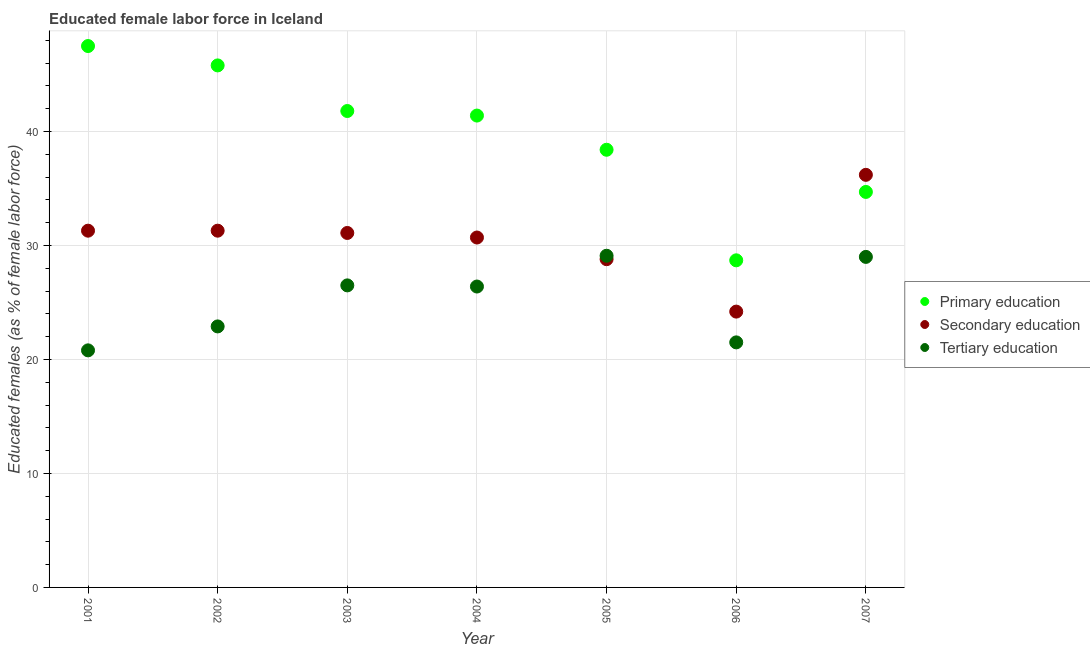Is the number of dotlines equal to the number of legend labels?
Make the answer very short. Yes. What is the percentage of female labor force who received tertiary education in 2007?
Keep it short and to the point. 29. Across all years, what is the maximum percentage of female labor force who received tertiary education?
Ensure brevity in your answer.  29.1. Across all years, what is the minimum percentage of female labor force who received secondary education?
Your answer should be compact. 24.2. In which year was the percentage of female labor force who received secondary education maximum?
Ensure brevity in your answer.  2007. In which year was the percentage of female labor force who received secondary education minimum?
Your answer should be compact. 2006. What is the total percentage of female labor force who received secondary education in the graph?
Your answer should be compact. 213.6. What is the difference between the percentage of female labor force who received primary education in 2004 and that in 2007?
Make the answer very short. 6.7. What is the difference between the percentage of female labor force who received primary education in 2002 and the percentage of female labor force who received tertiary education in 2005?
Your response must be concise. 16.7. What is the average percentage of female labor force who received primary education per year?
Make the answer very short. 39.76. In the year 2005, what is the difference between the percentage of female labor force who received primary education and percentage of female labor force who received secondary education?
Offer a very short reply. 9.6. In how many years, is the percentage of female labor force who received secondary education greater than 34 %?
Make the answer very short. 1. What is the ratio of the percentage of female labor force who received tertiary education in 2005 to that in 2007?
Your answer should be very brief. 1. Is the percentage of female labor force who received secondary education in 2004 less than that in 2005?
Give a very brief answer. No. Is the difference between the percentage of female labor force who received primary education in 2001 and 2006 greater than the difference between the percentage of female labor force who received tertiary education in 2001 and 2006?
Offer a terse response. Yes. What is the difference between the highest and the second highest percentage of female labor force who received primary education?
Make the answer very short. 1.7. What is the difference between the highest and the lowest percentage of female labor force who received primary education?
Your response must be concise. 18.8. Is it the case that in every year, the sum of the percentage of female labor force who received primary education and percentage of female labor force who received secondary education is greater than the percentage of female labor force who received tertiary education?
Ensure brevity in your answer.  Yes. Is the percentage of female labor force who received tertiary education strictly less than the percentage of female labor force who received secondary education over the years?
Your answer should be very brief. No. How many dotlines are there?
Your response must be concise. 3. What is the difference between two consecutive major ticks on the Y-axis?
Your answer should be very brief. 10. Are the values on the major ticks of Y-axis written in scientific E-notation?
Make the answer very short. No. Does the graph contain any zero values?
Provide a succinct answer. No. Does the graph contain grids?
Ensure brevity in your answer.  Yes. Where does the legend appear in the graph?
Provide a short and direct response. Center right. What is the title of the graph?
Your answer should be very brief. Educated female labor force in Iceland. What is the label or title of the X-axis?
Provide a short and direct response. Year. What is the label or title of the Y-axis?
Offer a terse response. Educated females (as % of female labor force). What is the Educated females (as % of female labor force) in Primary education in 2001?
Your answer should be compact. 47.5. What is the Educated females (as % of female labor force) in Secondary education in 2001?
Keep it short and to the point. 31.3. What is the Educated females (as % of female labor force) of Tertiary education in 2001?
Your answer should be very brief. 20.8. What is the Educated females (as % of female labor force) of Primary education in 2002?
Offer a terse response. 45.8. What is the Educated females (as % of female labor force) of Secondary education in 2002?
Provide a succinct answer. 31.3. What is the Educated females (as % of female labor force) in Tertiary education in 2002?
Offer a very short reply. 22.9. What is the Educated females (as % of female labor force) in Primary education in 2003?
Your answer should be compact. 41.8. What is the Educated females (as % of female labor force) of Secondary education in 2003?
Make the answer very short. 31.1. What is the Educated females (as % of female labor force) of Tertiary education in 2003?
Keep it short and to the point. 26.5. What is the Educated females (as % of female labor force) of Primary education in 2004?
Ensure brevity in your answer.  41.4. What is the Educated females (as % of female labor force) in Secondary education in 2004?
Offer a very short reply. 30.7. What is the Educated females (as % of female labor force) of Tertiary education in 2004?
Offer a very short reply. 26.4. What is the Educated females (as % of female labor force) in Primary education in 2005?
Make the answer very short. 38.4. What is the Educated females (as % of female labor force) in Secondary education in 2005?
Keep it short and to the point. 28.8. What is the Educated females (as % of female labor force) of Tertiary education in 2005?
Provide a short and direct response. 29.1. What is the Educated females (as % of female labor force) of Primary education in 2006?
Provide a short and direct response. 28.7. What is the Educated females (as % of female labor force) in Secondary education in 2006?
Keep it short and to the point. 24.2. What is the Educated females (as % of female labor force) of Tertiary education in 2006?
Your answer should be very brief. 21.5. What is the Educated females (as % of female labor force) in Primary education in 2007?
Make the answer very short. 34.7. What is the Educated females (as % of female labor force) in Secondary education in 2007?
Your response must be concise. 36.2. What is the Educated females (as % of female labor force) in Tertiary education in 2007?
Your answer should be compact. 29. Across all years, what is the maximum Educated females (as % of female labor force) of Primary education?
Ensure brevity in your answer.  47.5. Across all years, what is the maximum Educated females (as % of female labor force) in Secondary education?
Your response must be concise. 36.2. Across all years, what is the maximum Educated females (as % of female labor force) in Tertiary education?
Your answer should be very brief. 29.1. Across all years, what is the minimum Educated females (as % of female labor force) of Primary education?
Provide a short and direct response. 28.7. Across all years, what is the minimum Educated females (as % of female labor force) of Secondary education?
Your answer should be compact. 24.2. Across all years, what is the minimum Educated females (as % of female labor force) in Tertiary education?
Provide a short and direct response. 20.8. What is the total Educated females (as % of female labor force) in Primary education in the graph?
Provide a short and direct response. 278.3. What is the total Educated females (as % of female labor force) of Secondary education in the graph?
Keep it short and to the point. 213.6. What is the total Educated females (as % of female labor force) in Tertiary education in the graph?
Your answer should be compact. 176.2. What is the difference between the Educated females (as % of female labor force) of Primary education in 2001 and that in 2002?
Ensure brevity in your answer.  1.7. What is the difference between the Educated females (as % of female labor force) of Tertiary education in 2001 and that in 2002?
Make the answer very short. -2.1. What is the difference between the Educated females (as % of female labor force) of Tertiary education in 2001 and that in 2003?
Make the answer very short. -5.7. What is the difference between the Educated females (as % of female labor force) in Secondary education in 2001 and that in 2004?
Make the answer very short. 0.6. What is the difference between the Educated females (as % of female labor force) of Tertiary education in 2001 and that in 2004?
Provide a short and direct response. -5.6. What is the difference between the Educated females (as % of female labor force) in Primary education in 2001 and that in 2005?
Keep it short and to the point. 9.1. What is the difference between the Educated females (as % of female labor force) in Tertiary education in 2001 and that in 2005?
Offer a very short reply. -8.3. What is the difference between the Educated females (as % of female labor force) of Tertiary education in 2001 and that in 2006?
Your answer should be compact. -0.7. What is the difference between the Educated females (as % of female labor force) in Primary education in 2001 and that in 2007?
Your answer should be compact. 12.8. What is the difference between the Educated females (as % of female labor force) of Secondary education in 2001 and that in 2007?
Offer a very short reply. -4.9. What is the difference between the Educated females (as % of female labor force) of Tertiary education in 2001 and that in 2007?
Your response must be concise. -8.2. What is the difference between the Educated females (as % of female labor force) of Primary education in 2002 and that in 2003?
Provide a succinct answer. 4. What is the difference between the Educated females (as % of female labor force) of Tertiary education in 2002 and that in 2003?
Make the answer very short. -3.6. What is the difference between the Educated females (as % of female labor force) of Primary education in 2002 and that in 2004?
Make the answer very short. 4.4. What is the difference between the Educated females (as % of female labor force) of Tertiary education in 2002 and that in 2004?
Offer a terse response. -3.5. What is the difference between the Educated females (as % of female labor force) of Primary education in 2002 and that in 2005?
Offer a terse response. 7.4. What is the difference between the Educated females (as % of female labor force) in Tertiary education in 2002 and that in 2005?
Provide a succinct answer. -6.2. What is the difference between the Educated females (as % of female labor force) in Primary education in 2002 and that in 2006?
Make the answer very short. 17.1. What is the difference between the Educated females (as % of female labor force) of Secondary education in 2002 and that in 2006?
Your response must be concise. 7.1. What is the difference between the Educated females (as % of female labor force) in Tertiary education in 2002 and that in 2006?
Offer a terse response. 1.4. What is the difference between the Educated females (as % of female labor force) of Secondary education in 2002 and that in 2007?
Your answer should be very brief. -4.9. What is the difference between the Educated females (as % of female labor force) in Tertiary education in 2002 and that in 2007?
Offer a very short reply. -6.1. What is the difference between the Educated females (as % of female labor force) of Primary education in 2003 and that in 2004?
Offer a very short reply. 0.4. What is the difference between the Educated females (as % of female labor force) in Tertiary education in 2003 and that in 2004?
Provide a short and direct response. 0.1. What is the difference between the Educated females (as % of female labor force) of Secondary education in 2003 and that in 2005?
Offer a very short reply. 2.3. What is the difference between the Educated females (as % of female labor force) of Tertiary education in 2003 and that in 2006?
Your answer should be very brief. 5. What is the difference between the Educated females (as % of female labor force) in Primary education in 2003 and that in 2007?
Your answer should be very brief. 7.1. What is the difference between the Educated females (as % of female labor force) of Tertiary education in 2003 and that in 2007?
Make the answer very short. -2.5. What is the difference between the Educated females (as % of female labor force) in Primary education in 2004 and that in 2005?
Give a very brief answer. 3. What is the difference between the Educated females (as % of female labor force) in Secondary education in 2004 and that in 2005?
Your response must be concise. 1.9. What is the difference between the Educated females (as % of female labor force) of Tertiary education in 2004 and that in 2005?
Provide a short and direct response. -2.7. What is the difference between the Educated females (as % of female labor force) of Primary education in 2004 and that in 2006?
Provide a succinct answer. 12.7. What is the difference between the Educated females (as % of female labor force) in Primary education in 2004 and that in 2007?
Keep it short and to the point. 6.7. What is the difference between the Educated females (as % of female labor force) of Primary education in 2005 and that in 2006?
Offer a very short reply. 9.7. What is the difference between the Educated females (as % of female labor force) of Secondary education in 2005 and that in 2006?
Keep it short and to the point. 4.6. What is the difference between the Educated females (as % of female labor force) in Tertiary education in 2005 and that in 2006?
Offer a terse response. 7.6. What is the difference between the Educated females (as % of female labor force) in Primary education in 2006 and that in 2007?
Make the answer very short. -6. What is the difference between the Educated females (as % of female labor force) in Secondary education in 2006 and that in 2007?
Offer a terse response. -12. What is the difference between the Educated females (as % of female labor force) of Primary education in 2001 and the Educated females (as % of female labor force) of Secondary education in 2002?
Offer a very short reply. 16.2. What is the difference between the Educated females (as % of female labor force) of Primary education in 2001 and the Educated females (as % of female labor force) of Tertiary education in 2002?
Provide a short and direct response. 24.6. What is the difference between the Educated females (as % of female labor force) of Secondary education in 2001 and the Educated females (as % of female labor force) of Tertiary education in 2002?
Ensure brevity in your answer.  8.4. What is the difference between the Educated females (as % of female labor force) of Primary education in 2001 and the Educated females (as % of female labor force) of Secondary education in 2003?
Provide a short and direct response. 16.4. What is the difference between the Educated females (as % of female labor force) of Primary education in 2001 and the Educated females (as % of female labor force) of Secondary education in 2004?
Offer a very short reply. 16.8. What is the difference between the Educated females (as % of female labor force) of Primary education in 2001 and the Educated females (as % of female labor force) of Tertiary education in 2004?
Provide a short and direct response. 21.1. What is the difference between the Educated females (as % of female labor force) in Primary education in 2001 and the Educated females (as % of female labor force) in Secondary education in 2005?
Provide a short and direct response. 18.7. What is the difference between the Educated females (as % of female labor force) of Secondary education in 2001 and the Educated females (as % of female labor force) of Tertiary education in 2005?
Provide a short and direct response. 2.2. What is the difference between the Educated females (as % of female labor force) in Primary education in 2001 and the Educated females (as % of female labor force) in Secondary education in 2006?
Provide a succinct answer. 23.3. What is the difference between the Educated females (as % of female labor force) of Primary education in 2001 and the Educated females (as % of female labor force) of Tertiary education in 2007?
Your answer should be very brief. 18.5. What is the difference between the Educated females (as % of female labor force) in Primary education in 2002 and the Educated females (as % of female labor force) in Tertiary education in 2003?
Your answer should be compact. 19.3. What is the difference between the Educated females (as % of female labor force) in Primary education in 2002 and the Educated females (as % of female labor force) in Secondary education in 2004?
Your answer should be very brief. 15.1. What is the difference between the Educated females (as % of female labor force) in Primary education in 2002 and the Educated females (as % of female labor force) in Secondary education in 2005?
Offer a terse response. 17. What is the difference between the Educated females (as % of female labor force) in Primary education in 2002 and the Educated females (as % of female labor force) in Tertiary education in 2005?
Ensure brevity in your answer.  16.7. What is the difference between the Educated females (as % of female labor force) of Primary education in 2002 and the Educated females (as % of female labor force) of Secondary education in 2006?
Make the answer very short. 21.6. What is the difference between the Educated females (as % of female labor force) in Primary education in 2002 and the Educated females (as % of female labor force) in Tertiary education in 2006?
Keep it short and to the point. 24.3. What is the difference between the Educated females (as % of female labor force) in Secondary education in 2002 and the Educated females (as % of female labor force) in Tertiary education in 2006?
Provide a short and direct response. 9.8. What is the difference between the Educated females (as % of female labor force) in Primary education in 2002 and the Educated females (as % of female labor force) in Secondary education in 2007?
Make the answer very short. 9.6. What is the difference between the Educated females (as % of female labor force) of Primary education in 2003 and the Educated females (as % of female labor force) of Tertiary education in 2004?
Provide a short and direct response. 15.4. What is the difference between the Educated females (as % of female labor force) of Secondary education in 2003 and the Educated females (as % of female labor force) of Tertiary education in 2004?
Give a very brief answer. 4.7. What is the difference between the Educated females (as % of female labor force) in Primary education in 2003 and the Educated females (as % of female labor force) in Tertiary education in 2006?
Provide a succinct answer. 20.3. What is the difference between the Educated females (as % of female labor force) of Secondary education in 2003 and the Educated females (as % of female labor force) of Tertiary education in 2006?
Make the answer very short. 9.6. What is the difference between the Educated females (as % of female labor force) in Primary education in 2003 and the Educated females (as % of female labor force) in Secondary education in 2007?
Provide a short and direct response. 5.6. What is the difference between the Educated females (as % of female labor force) of Primary education in 2004 and the Educated females (as % of female labor force) of Tertiary education in 2005?
Your answer should be compact. 12.3. What is the difference between the Educated females (as % of female labor force) in Primary education in 2004 and the Educated females (as % of female labor force) in Secondary education in 2006?
Provide a succinct answer. 17.2. What is the difference between the Educated females (as % of female labor force) in Primary education in 2004 and the Educated females (as % of female labor force) in Tertiary education in 2006?
Offer a very short reply. 19.9. What is the difference between the Educated females (as % of female labor force) in Secondary education in 2004 and the Educated females (as % of female labor force) in Tertiary education in 2006?
Give a very brief answer. 9.2. What is the difference between the Educated females (as % of female labor force) of Secondary education in 2004 and the Educated females (as % of female labor force) of Tertiary education in 2007?
Provide a short and direct response. 1.7. What is the difference between the Educated females (as % of female labor force) in Primary education in 2005 and the Educated females (as % of female labor force) in Tertiary education in 2006?
Keep it short and to the point. 16.9. What is the difference between the Educated females (as % of female labor force) in Primary education in 2006 and the Educated females (as % of female labor force) in Secondary education in 2007?
Make the answer very short. -7.5. What is the difference between the Educated females (as % of female labor force) in Secondary education in 2006 and the Educated females (as % of female labor force) in Tertiary education in 2007?
Provide a short and direct response. -4.8. What is the average Educated females (as % of female labor force) of Primary education per year?
Offer a terse response. 39.76. What is the average Educated females (as % of female labor force) in Secondary education per year?
Your answer should be compact. 30.51. What is the average Educated females (as % of female labor force) in Tertiary education per year?
Provide a short and direct response. 25.17. In the year 2001, what is the difference between the Educated females (as % of female labor force) in Primary education and Educated females (as % of female labor force) in Secondary education?
Make the answer very short. 16.2. In the year 2001, what is the difference between the Educated females (as % of female labor force) in Primary education and Educated females (as % of female labor force) in Tertiary education?
Keep it short and to the point. 26.7. In the year 2002, what is the difference between the Educated females (as % of female labor force) of Primary education and Educated females (as % of female labor force) of Secondary education?
Your answer should be very brief. 14.5. In the year 2002, what is the difference between the Educated females (as % of female labor force) of Primary education and Educated females (as % of female labor force) of Tertiary education?
Provide a short and direct response. 22.9. In the year 2003, what is the difference between the Educated females (as % of female labor force) in Primary education and Educated females (as % of female labor force) in Tertiary education?
Your answer should be very brief. 15.3. In the year 2003, what is the difference between the Educated females (as % of female labor force) of Secondary education and Educated females (as % of female labor force) of Tertiary education?
Offer a very short reply. 4.6. In the year 2004, what is the difference between the Educated females (as % of female labor force) in Primary education and Educated females (as % of female labor force) in Secondary education?
Your answer should be compact. 10.7. In the year 2004, what is the difference between the Educated females (as % of female labor force) of Secondary education and Educated females (as % of female labor force) of Tertiary education?
Offer a terse response. 4.3. In the year 2005, what is the difference between the Educated females (as % of female labor force) of Primary education and Educated females (as % of female labor force) of Tertiary education?
Ensure brevity in your answer.  9.3. In the year 2005, what is the difference between the Educated females (as % of female labor force) of Secondary education and Educated females (as % of female labor force) of Tertiary education?
Offer a very short reply. -0.3. In the year 2006, what is the difference between the Educated females (as % of female labor force) in Primary education and Educated females (as % of female labor force) in Secondary education?
Give a very brief answer. 4.5. In the year 2006, what is the difference between the Educated females (as % of female labor force) of Secondary education and Educated females (as % of female labor force) of Tertiary education?
Your answer should be compact. 2.7. In the year 2007, what is the difference between the Educated females (as % of female labor force) of Primary education and Educated females (as % of female labor force) of Secondary education?
Give a very brief answer. -1.5. In the year 2007, what is the difference between the Educated females (as % of female labor force) in Secondary education and Educated females (as % of female labor force) in Tertiary education?
Provide a succinct answer. 7.2. What is the ratio of the Educated females (as % of female labor force) of Primary education in 2001 to that in 2002?
Keep it short and to the point. 1.04. What is the ratio of the Educated females (as % of female labor force) of Tertiary education in 2001 to that in 2002?
Your response must be concise. 0.91. What is the ratio of the Educated females (as % of female labor force) of Primary education in 2001 to that in 2003?
Your answer should be compact. 1.14. What is the ratio of the Educated females (as % of female labor force) of Secondary education in 2001 to that in 2003?
Your response must be concise. 1.01. What is the ratio of the Educated females (as % of female labor force) in Tertiary education in 2001 to that in 2003?
Your answer should be compact. 0.78. What is the ratio of the Educated females (as % of female labor force) of Primary education in 2001 to that in 2004?
Provide a succinct answer. 1.15. What is the ratio of the Educated females (as % of female labor force) in Secondary education in 2001 to that in 2004?
Make the answer very short. 1.02. What is the ratio of the Educated females (as % of female labor force) in Tertiary education in 2001 to that in 2004?
Your response must be concise. 0.79. What is the ratio of the Educated females (as % of female labor force) of Primary education in 2001 to that in 2005?
Give a very brief answer. 1.24. What is the ratio of the Educated females (as % of female labor force) of Secondary education in 2001 to that in 2005?
Your answer should be very brief. 1.09. What is the ratio of the Educated females (as % of female labor force) in Tertiary education in 2001 to that in 2005?
Keep it short and to the point. 0.71. What is the ratio of the Educated females (as % of female labor force) of Primary education in 2001 to that in 2006?
Ensure brevity in your answer.  1.66. What is the ratio of the Educated females (as % of female labor force) of Secondary education in 2001 to that in 2006?
Your response must be concise. 1.29. What is the ratio of the Educated females (as % of female labor force) of Tertiary education in 2001 to that in 2006?
Provide a succinct answer. 0.97. What is the ratio of the Educated females (as % of female labor force) of Primary education in 2001 to that in 2007?
Your response must be concise. 1.37. What is the ratio of the Educated females (as % of female labor force) of Secondary education in 2001 to that in 2007?
Offer a terse response. 0.86. What is the ratio of the Educated females (as % of female labor force) in Tertiary education in 2001 to that in 2007?
Your answer should be very brief. 0.72. What is the ratio of the Educated females (as % of female labor force) of Primary education in 2002 to that in 2003?
Your answer should be compact. 1.1. What is the ratio of the Educated females (as % of female labor force) in Secondary education in 2002 to that in 2003?
Offer a very short reply. 1.01. What is the ratio of the Educated females (as % of female labor force) of Tertiary education in 2002 to that in 2003?
Your response must be concise. 0.86. What is the ratio of the Educated females (as % of female labor force) in Primary education in 2002 to that in 2004?
Provide a short and direct response. 1.11. What is the ratio of the Educated females (as % of female labor force) of Secondary education in 2002 to that in 2004?
Offer a terse response. 1.02. What is the ratio of the Educated females (as % of female labor force) in Tertiary education in 2002 to that in 2004?
Provide a succinct answer. 0.87. What is the ratio of the Educated females (as % of female labor force) in Primary education in 2002 to that in 2005?
Make the answer very short. 1.19. What is the ratio of the Educated females (as % of female labor force) of Secondary education in 2002 to that in 2005?
Keep it short and to the point. 1.09. What is the ratio of the Educated females (as % of female labor force) in Tertiary education in 2002 to that in 2005?
Make the answer very short. 0.79. What is the ratio of the Educated females (as % of female labor force) in Primary education in 2002 to that in 2006?
Give a very brief answer. 1.6. What is the ratio of the Educated females (as % of female labor force) of Secondary education in 2002 to that in 2006?
Provide a short and direct response. 1.29. What is the ratio of the Educated females (as % of female labor force) of Tertiary education in 2002 to that in 2006?
Your response must be concise. 1.07. What is the ratio of the Educated females (as % of female labor force) in Primary education in 2002 to that in 2007?
Provide a succinct answer. 1.32. What is the ratio of the Educated females (as % of female labor force) in Secondary education in 2002 to that in 2007?
Make the answer very short. 0.86. What is the ratio of the Educated females (as % of female labor force) of Tertiary education in 2002 to that in 2007?
Make the answer very short. 0.79. What is the ratio of the Educated females (as % of female labor force) of Primary education in 2003 to that in 2004?
Keep it short and to the point. 1.01. What is the ratio of the Educated females (as % of female labor force) in Secondary education in 2003 to that in 2004?
Provide a succinct answer. 1.01. What is the ratio of the Educated females (as % of female labor force) in Tertiary education in 2003 to that in 2004?
Offer a very short reply. 1. What is the ratio of the Educated females (as % of female labor force) of Primary education in 2003 to that in 2005?
Give a very brief answer. 1.09. What is the ratio of the Educated females (as % of female labor force) in Secondary education in 2003 to that in 2005?
Make the answer very short. 1.08. What is the ratio of the Educated females (as % of female labor force) in Tertiary education in 2003 to that in 2005?
Your response must be concise. 0.91. What is the ratio of the Educated females (as % of female labor force) of Primary education in 2003 to that in 2006?
Keep it short and to the point. 1.46. What is the ratio of the Educated females (as % of female labor force) of Secondary education in 2003 to that in 2006?
Your response must be concise. 1.29. What is the ratio of the Educated females (as % of female labor force) of Tertiary education in 2003 to that in 2006?
Provide a short and direct response. 1.23. What is the ratio of the Educated females (as % of female labor force) of Primary education in 2003 to that in 2007?
Your response must be concise. 1.2. What is the ratio of the Educated females (as % of female labor force) in Secondary education in 2003 to that in 2007?
Your response must be concise. 0.86. What is the ratio of the Educated females (as % of female labor force) of Tertiary education in 2003 to that in 2007?
Offer a very short reply. 0.91. What is the ratio of the Educated females (as % of female labor force) in Primary education in 2004 to that in 2005?
Your answer should be compact. 1.08. What is the ratio of the Educated females (as % of female labor force) in Secondary education in 2004 to that in 2005?
Make the answer very short. 1.07. What is the ratio of the Educated females (as % of female labor force) in Tertiary education in 2004 to that in 2005?
Ensure brevity in your answer.  0.91. What is the ratio of the Educated females (as % of female labor force) in Primary education in 2004 to that in 2006?
Your answer should be compact. 1.44. What is the ratio of the Educated females (as % of female labor force) of Secondary education in 2004 to that in 2006?
Your answer should be very brief. 1.27. What is the ratio of the Educated females (as % of female labor force) of Tertiary education in 2004 to that in 2006?
Ensure brevity in your answer.  1.23. What is the ratio of the Educated females (as % of female labor force) in Primary education in 2004 to that in 2007?
Your answer should be compact. 1.19. What is the ratio of the Educated females (as % of female labor force) in Secondary education in 2004 to that in 2007?
Give a very brief answer. 0.85. What is the ratio of the Educated females (as % of female labor force) of Tertiary education in 2004 to that in 2007?
Your answer should be very brief. 0.91. What is the ratio of the Educated females (as % of female labor force) of Primary education in 2005 to that in 2006?
Give a very brief answer. 1.34. What is the ratio of the Educated females (as % of female labor force) in Secondary education in 2005 to that in 2006?
Your answer should be very brief. 1.19. What is the ratio of the Educated females (as % of female labor force) of Tertiary education in 2005 to that in 2006?
Offer a terse response. 1.35. What is the ratio of the Educated females (as % of female labor force) in Primary education in 2005 to that in 2007?
Your answer should be compact. 1.11. What is the ratio of the Educated females (as % of female labor force) in Secondary education in 2005 to that in 2007?
Give a very brief answer. 0.8. What is the ratio of the Educated females (as % of female labor force) of Primary education in 2006 to that in 2007?
Your answer should be very brief. 0.83. What is the ratio of the Educated females (as % of female labor force) of Secondary education in 2006 to that in 2007?
Your answer should be compact. 0.67. What is the ratio of the Educated females (as % of female labor force) of Tertiary education in 2006 to that in 2007?
Your response must be concise. 0.74. What is the difference between the highest and the second highest Educated females (as % of female labor force) of Secondary education?
Give a very brief answer. 4.9. What is the difference between the highest and the lowest Educated females (as % of female labor force) of Tertiary education?
Your answer should be compact. 8.3. 